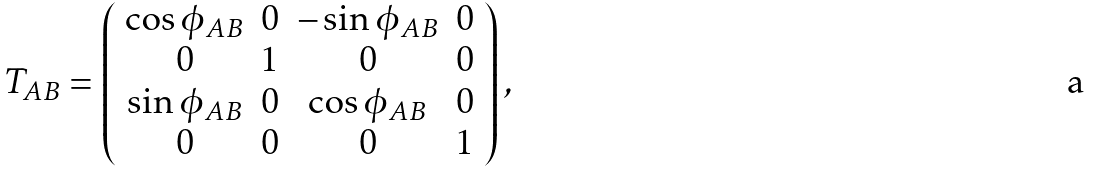<formula> <loc_0><loc_0><loc_500><loc_500>T _ { A B } = \left ( \begin{array} { c c c c } \cos \phi _ { A B } & 0 & - \sin \phi _ { A B } & 0 \\ 0 & 1 & 0 & 0 \\ \sin \phi _ { A B } & 0 & \cos \phi _ { A B } & 0 \\ 0 & 0 & 0 & 1 \end{array} \right ) ,</formula> 